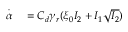<formula> <loc_0><loc_0><loc_500><loc_500>\begin{array} { r l } { \overset { \cdot } { \alpha } } & = C _ { d } \gamma _ { r } ( \xi _ { 0 } I _ { 2 } + I _ { 1 } \sqrt { I _ { 2 } } ) } \end{array}</formula> 